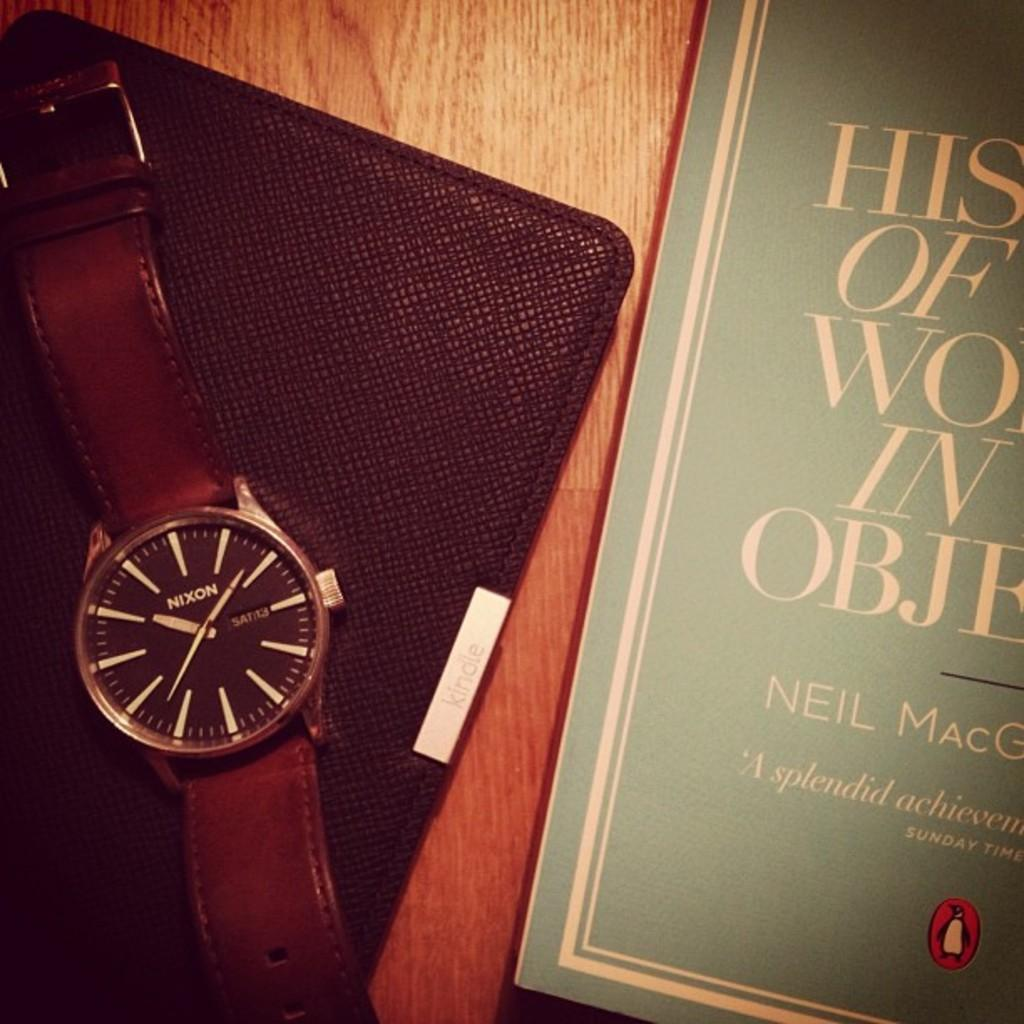<image>
Render a clear and concise summary of the photo. A Nixon watch sits next to a book written by someone named Neil. 